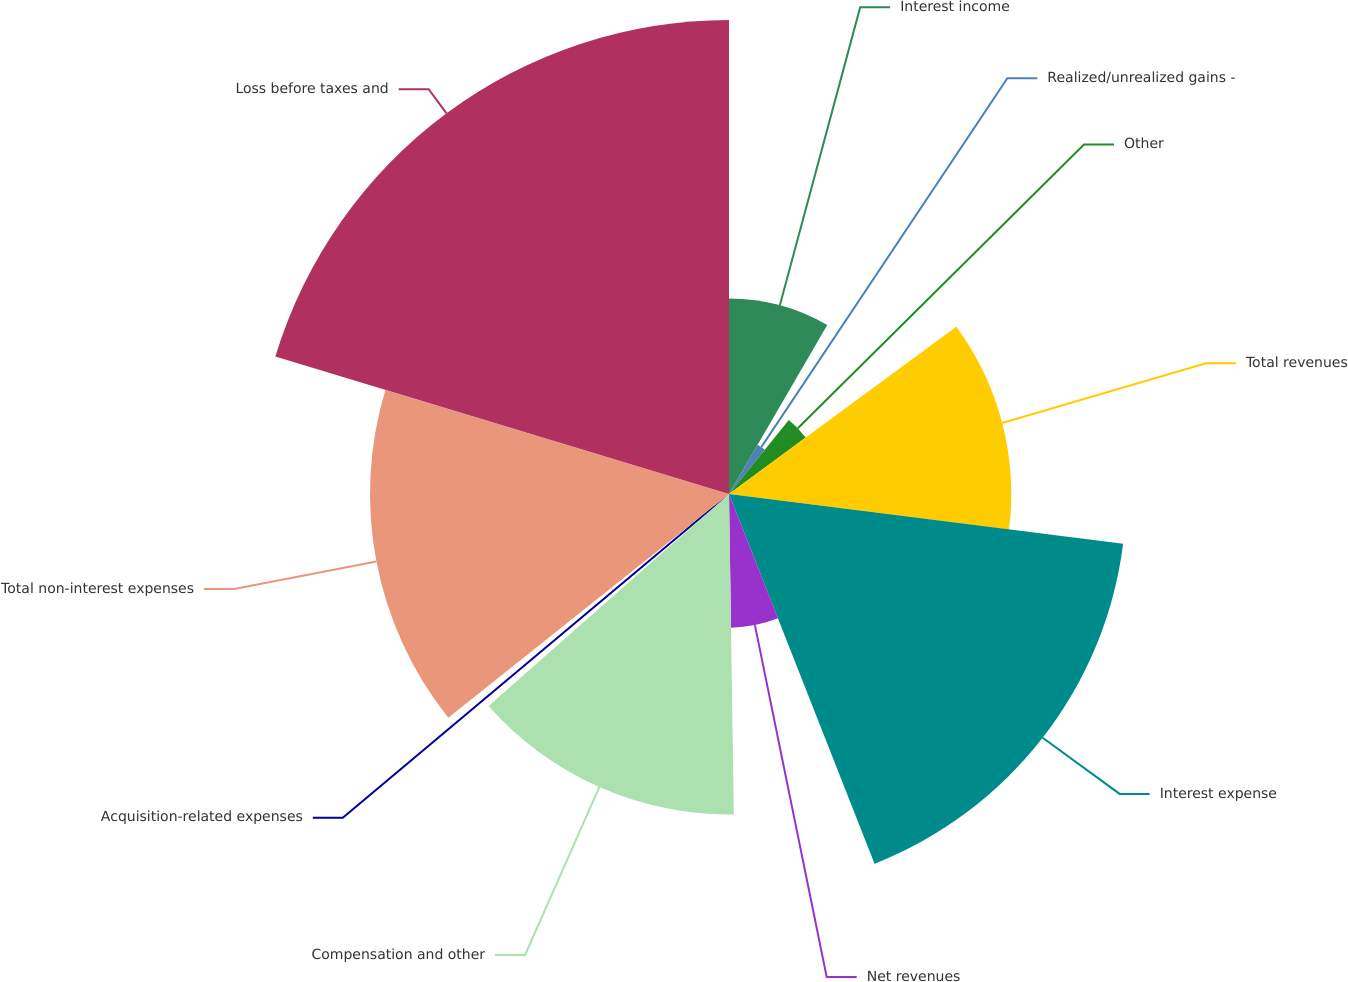Convert chart to OTSL. <chart><loc_0><loc_0><loc_500><loc_500><pie_chart><fcel>Interest income<fcel>Realized/unrealized gains -<fcel>Other<fcel>Total revenues<fcel>Interest expense<fcel>Net revenues<fcel>Compensation and other<fcel>Acquisition-related expenses<fcel>Total non-interest expenses<fcel>Loss before taxes and<nl><fcel>8.38%<fcel>2.44%<fcel>4.08%<fcel>12.1%<fcel>17.03%<fcel>5.73%<fcel>13.74%<fcel>0.79%<fcel>15.39%<fcel>20.32%<nl></chart> 